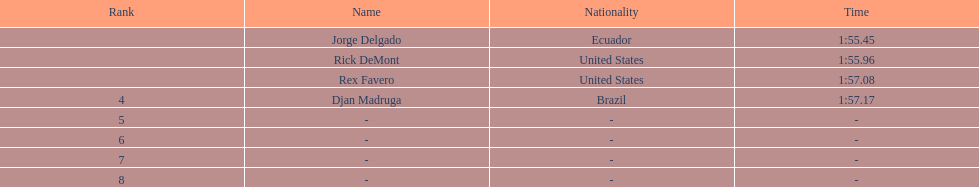Who achieved the top time? Jorge Delgado. 